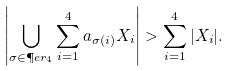<formula> <loc_0><loc_0><loc_500><loc_500>\left | \bigcup _ { \sigma \in \P e r _ { 4 } } \sum _ { i = 1 } ^ { 4 } a _ { \sigma ( i ) } X _ { i } \right | > \sum _ { i = 1 } ^ { 4 } | X _ { i } | .</formula> 